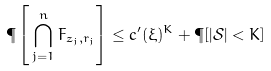<formula> <loc_0><loc_0><loc_500><loc_500>\P \left [ \, \bigcap _ { j = 1 } ^ { n } F _ { z _ { j } , r _ { j } } \right ] \leq c ^ { \prime } ( \xi ) ^ { K } + \P [ | \mathcal { S } | < K ]</formula> 